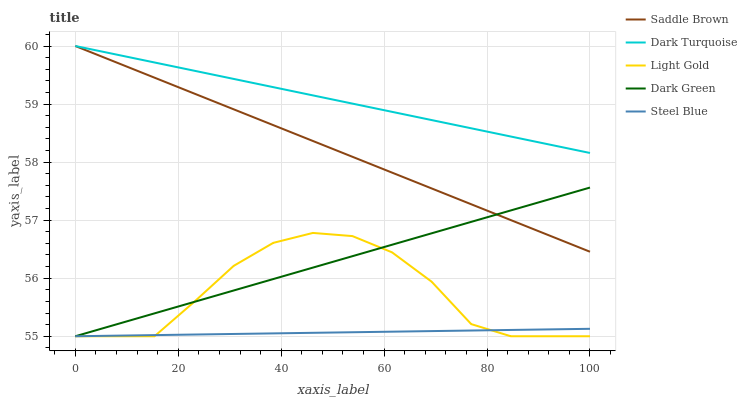Does Steel Blue have the minimum area under the curve?
Answer yes or no. Yes. Does Dark Turquoise have the maximum area under the curve?
Answer yes or no. Yes. Does Light Gold have the minimum area under the curve?
Answer yes or no. No. Does Light Gold have the maximum area under the curve?
Answer yes or no. No. Is Steel Blue the smoothest?
Answer yes or no. Yes. Is Light Gold the roughest?
Answer yes or no. Yes. Is Light Gold the smoothest?
Answer yes or no. No. Is Steel Blue the roughest?
Answer yes or no. No. Does Steel Blue have the lowest value?
Answer yes or no. Yes. Does Saddle Brown have the lowest value?
Answer yes or no. No. Does Saddle Brown have the highest value?
Answer yes or no. Yes. Does Light Gold have the highest value?
Answer yes or no. No. Is Light Gold less than Saddle Brown?
Answer yes or no. Yes. Is Saddle Brown greater than Light Gold?
Answer yes or no. Yes. Does Saddle Brown intersect Dark Turquoise?
Answer yes or no. Yes. Is Saddle Brown less than Dark Turquoise?
Answer yes or no. No. Is Saddle Brown greater than Dark Turquoise?
Answer yes or no. No. Does Light Gold intersect Saddle Brown?
Answer yes or no. No. 